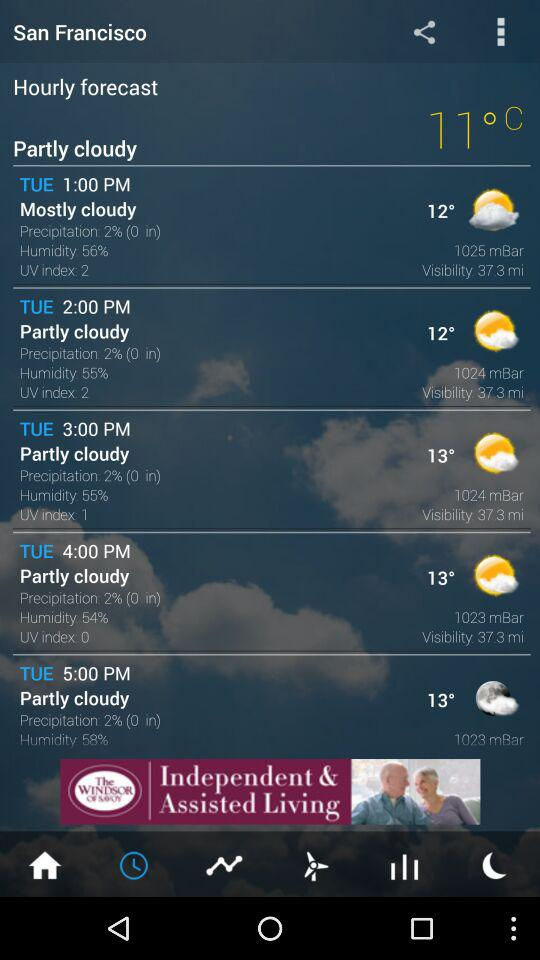What is the visibility at 4:00 PM? The visibility at 4:00 PM is 37.3 miles. 